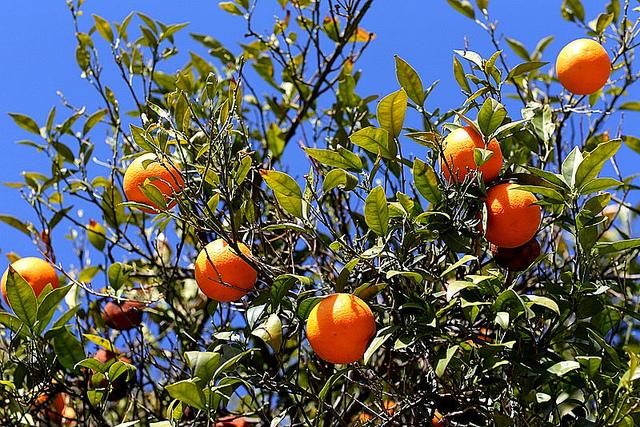Is the fruit ripe?
Give a very brief answer. Yes. What fruit is pictured on the tree?
Quick response, please. Oranges. Is the sky blue?
Short answer required. Yes. 